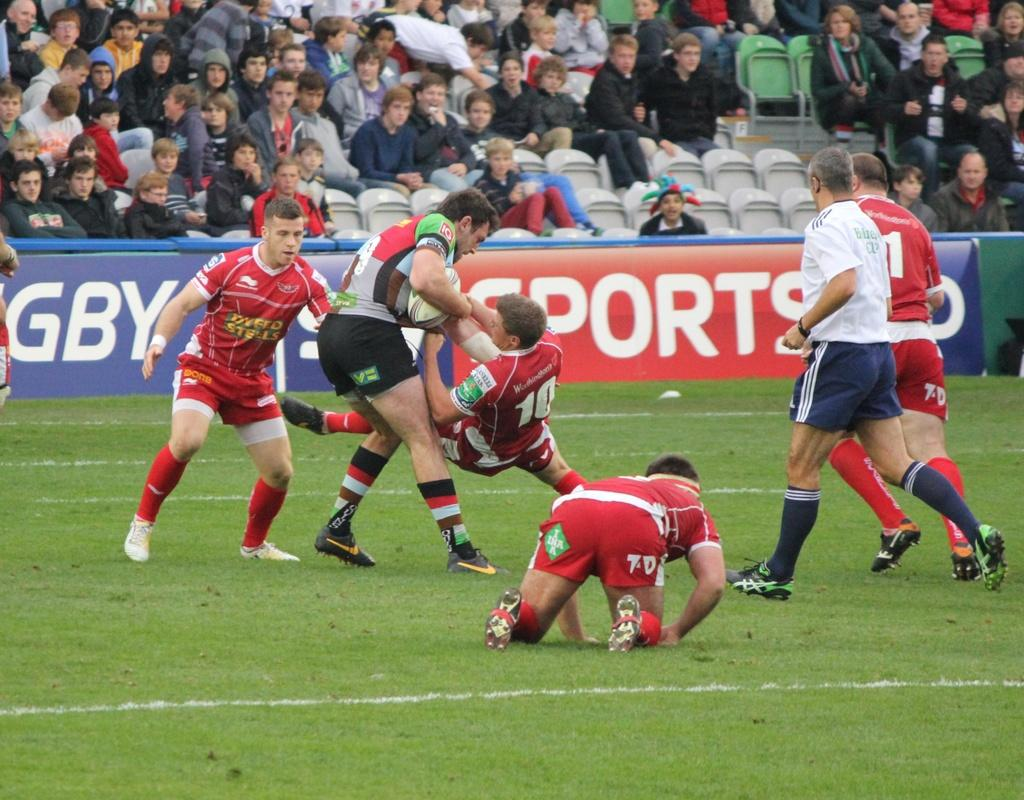<image>
Present a compact description of the photo's key features. Two football players holding one another including one wearing the number 10. 